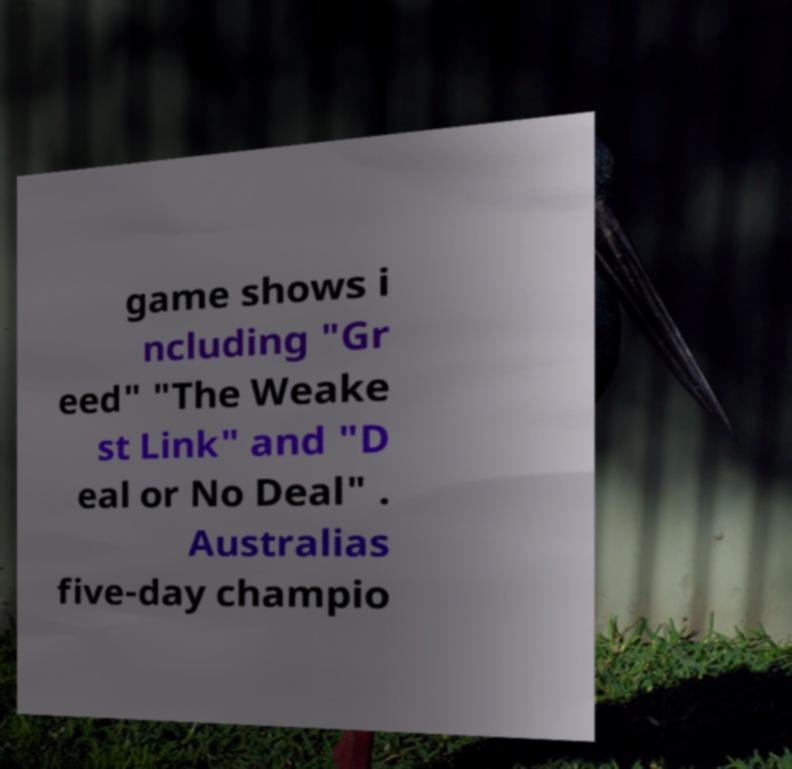I need the written content from this picture converted into text. Can you do that? game shows i ncluding "Gr eed" "The Weake st Link" and "D eal or No Deal" . Australias five-day champio 